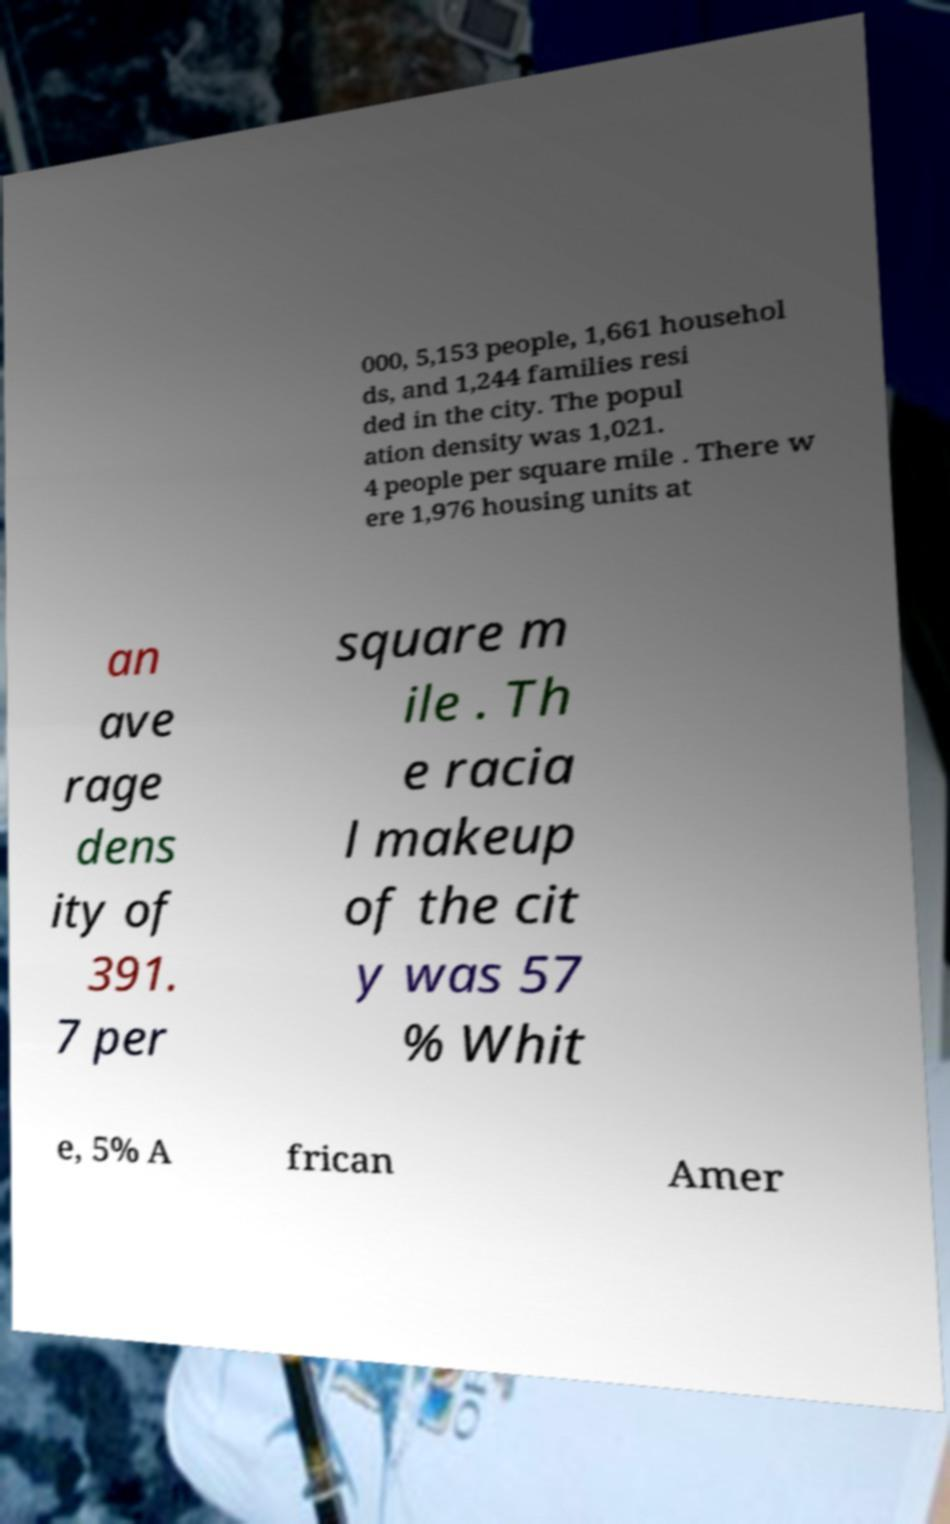Can you accurately transcribe the text from the provided image for me? 000, 5,153 people, 1,661 househol ds, and 1,244 families resi ded in the city. The popul ation density was 1,021. 4 people per square mile . There w ere 1,976 housing units at an ave rage dens ity of 391. 7 per square m ile . Th e racia l makeup of the cit y was 57 % Whit e, 5% A frican Amer 